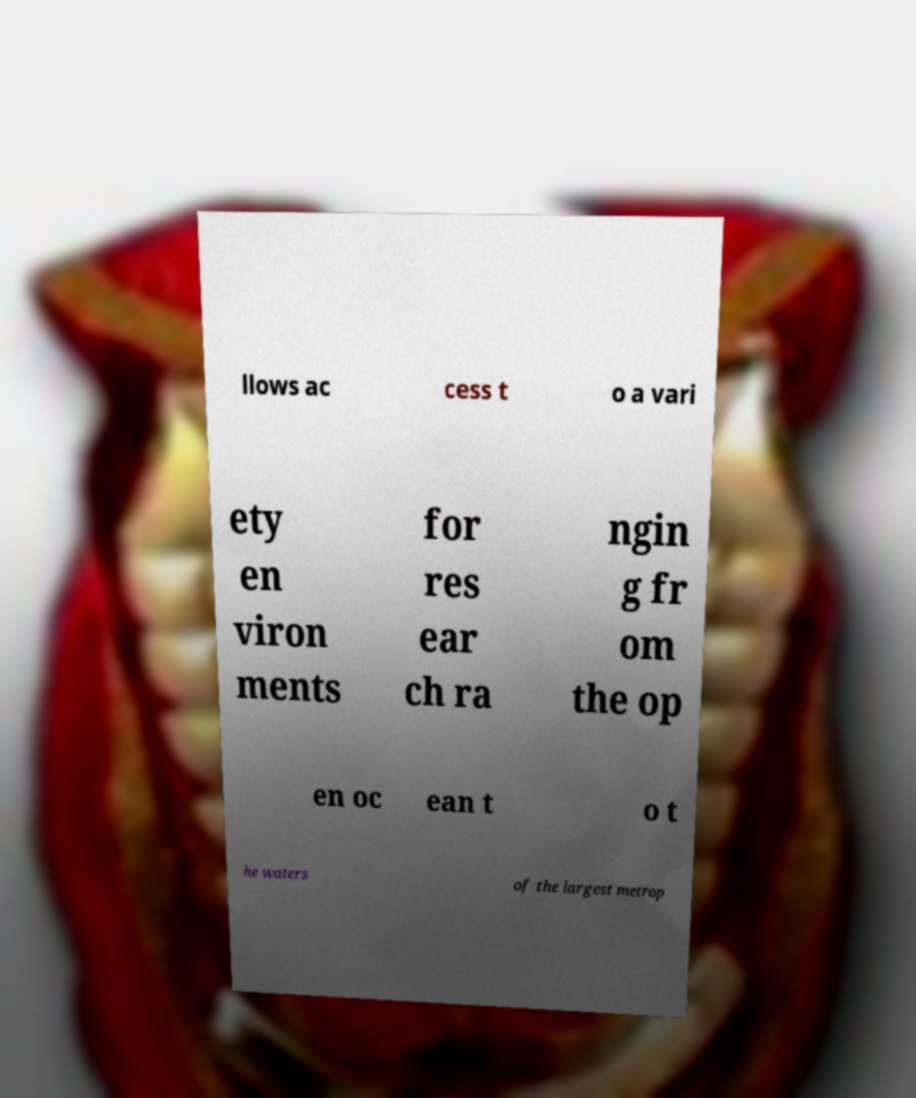Could you assist in decoding the text presented in this image and type it out clearly? llows ac cess t o a vari ety en viron ments for res ear ch ra ngin g fr om the op en oc ean t o t he waters of the largest metrop 